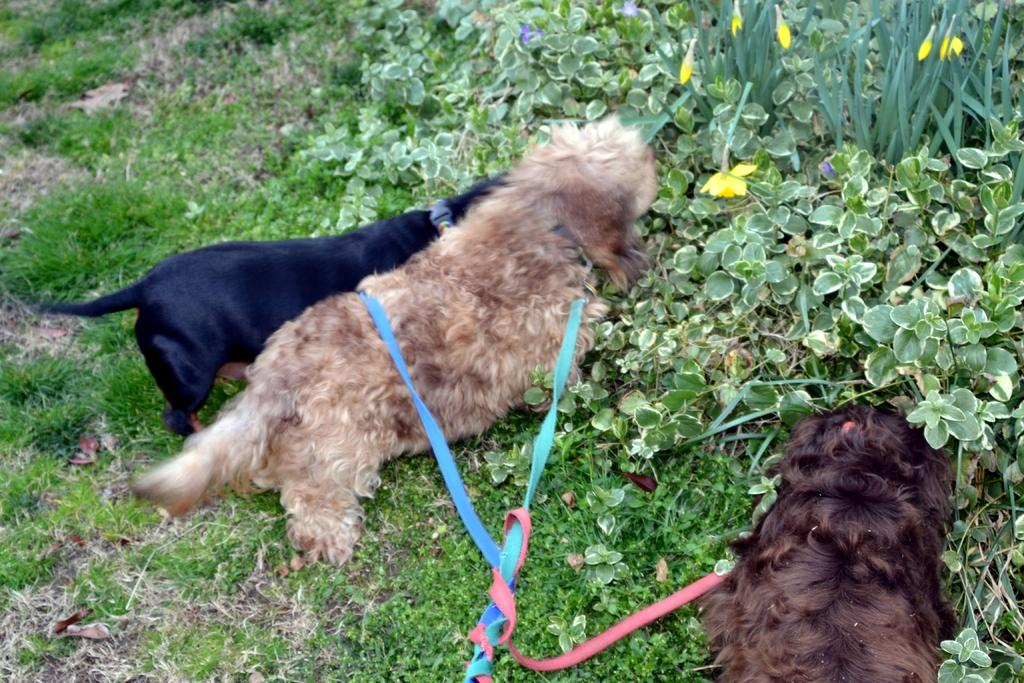What animals can be seen in the image? There are dogs in the image. Where are the dogs standing? The dogs are standing on the grass. How are the dogs secured in the image? The dogs are tied with belts. What type of vegetation is present in the image? There are plants with flowers in the image. Where are the plants with flowers located? The plants with flowers are on the ground. What type of cabbage is being washed at the faucet in the image? There is no cabbage or faucet present in the image. 